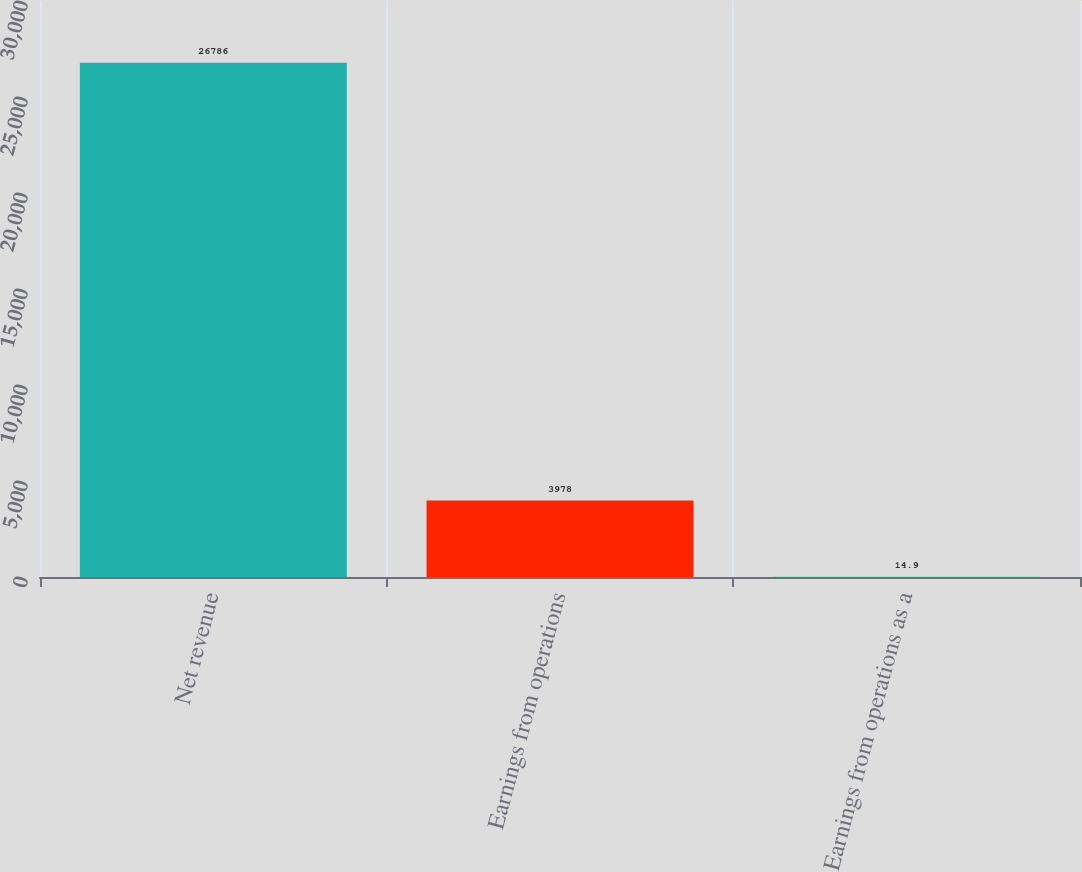<chart> <loc_0><loc_0><loc_500><loc_500><bar_chart><fcel>Net revenue<fcel>Earnings from operations<fcel>Earnings from operations as a<nl><fcel>26786<fcel>3978<fcel>14.9<nl></chart> 